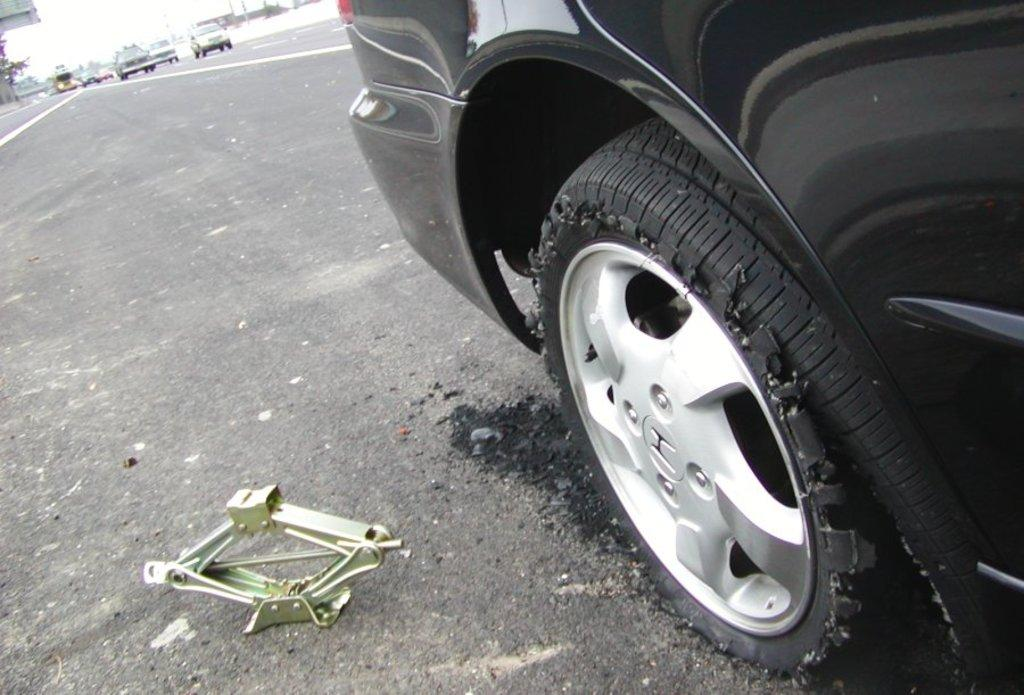What is the main subject of the image? There is an object in the image. What else can be seen in the image besides the object? There are vehicles on the road in the image. What is visible in the background of the image? The sky is visible in the background of the image. Are there any other objects or features in the background? Yes, there are other objects in the background of the image. Can you see any animals jumping in the zoo in the image? There is no zoo or animals jumping in the image; it only features an object, vehicles on the road, and the sky in the background. 